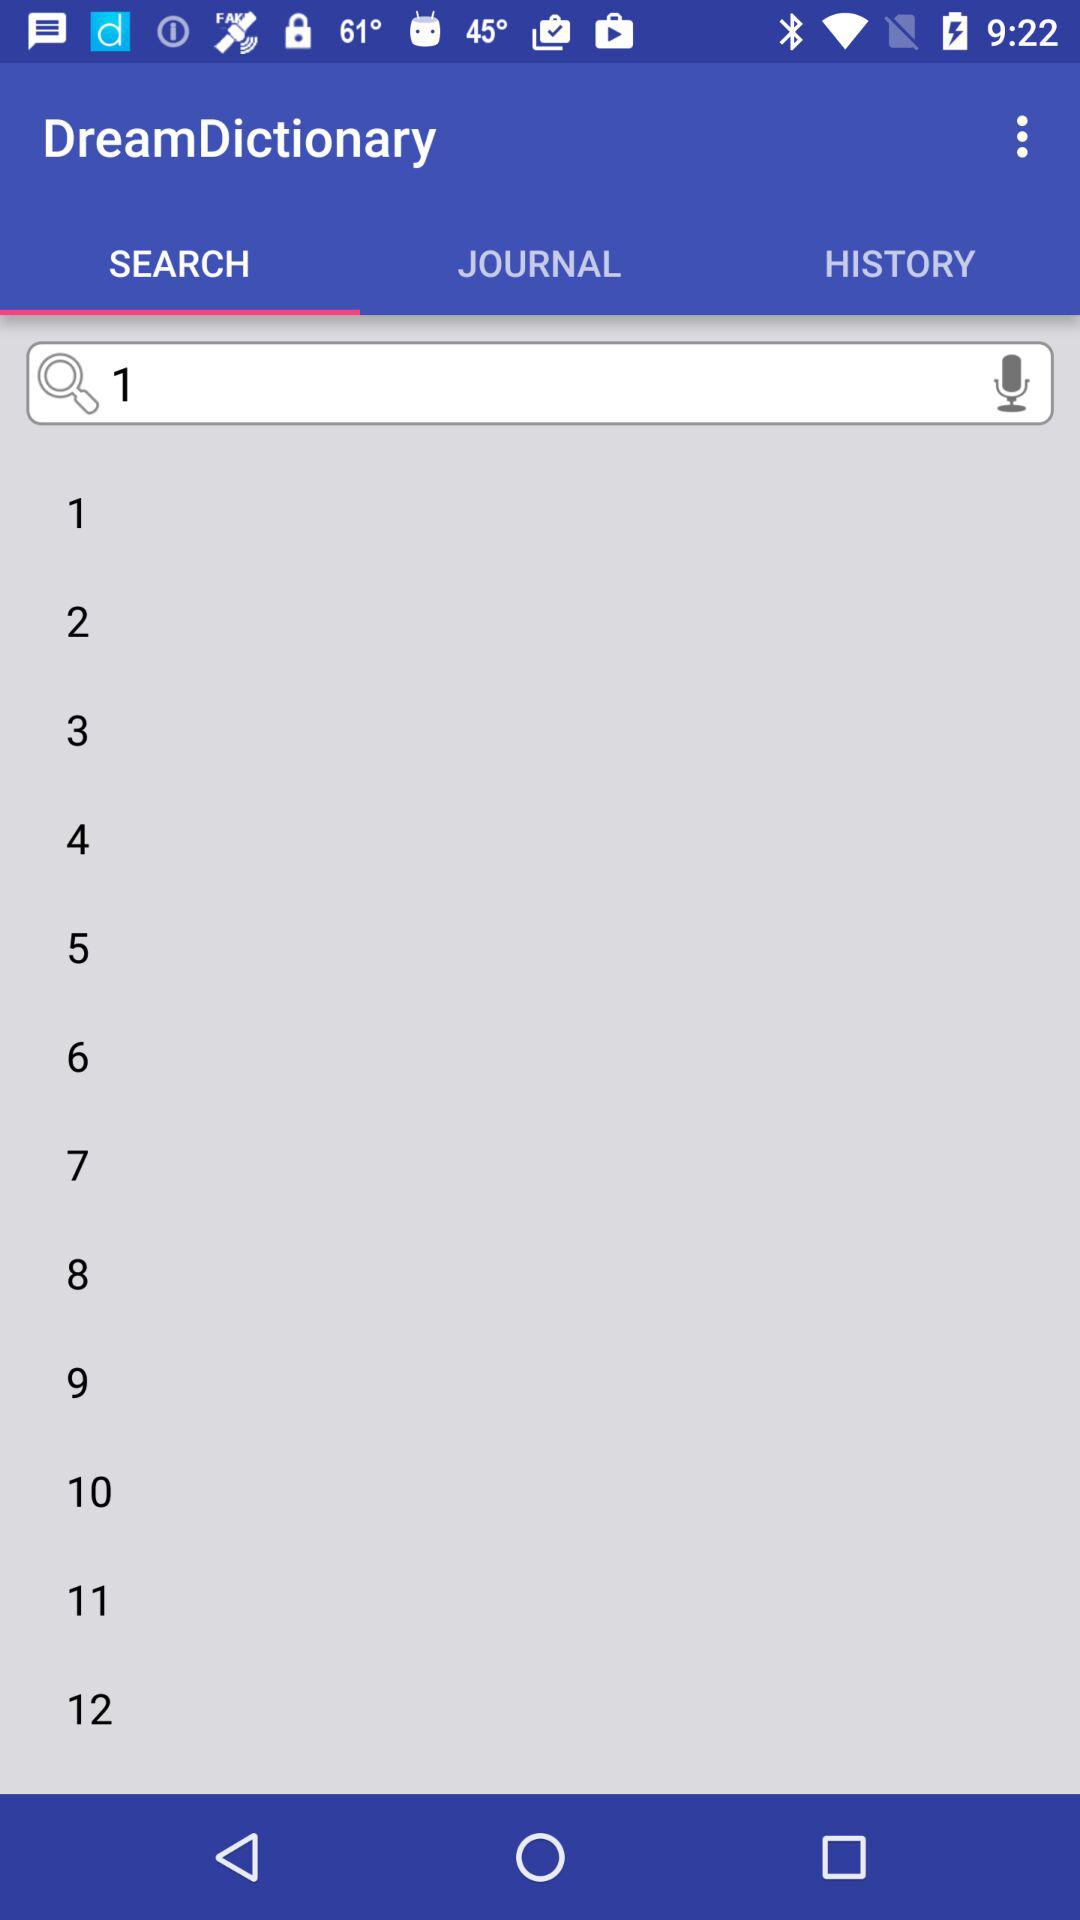What is the searched number? The searched number is 1. 